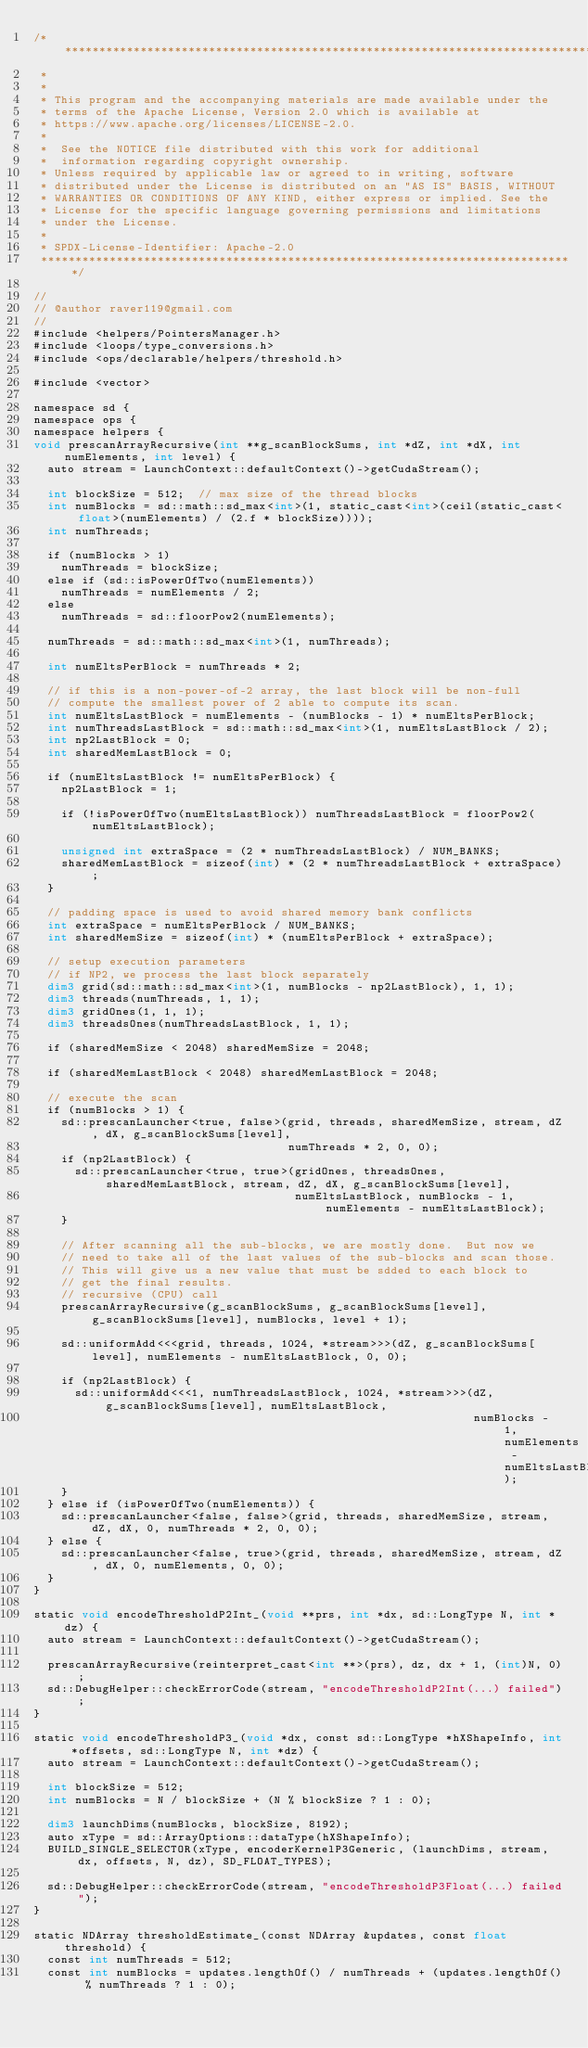<code> <loc_0><loc_0><loc_500><loc_500><_Cuda_>/* ******************************************************************************
 *
 *
 * This program and the accompanying materials are made available under the
 * terms of the Apache License, Version 2.0 which is available at
 * https://www.apache.org/licenses/LICENSE-2.0.
 *
 *  See the NOTICE file distributed with this work for additional
 *  information regarding copyright ownership.
 * Unless required by applicable law or agreed to in writing, software
 * distributed under the License is distributed on an "AS IS" BASIS, WITHOUT
 * WARRANTIES OR CONDITIONS OF ANY KIND, either express or implied. See the
 * License for the specific language governing permissions and limitations
 * under the License.
 *
 * SPDX-License-Identifier: Apache-2.0
 ******************************************************************************/

//
// @author raver119@gmail.com
//
#include <helpers/PointersManager.h>
#include <loops/type_conversions.h>
#include <ops/declarable/helpers/threshold.h>

#include <vector>

namespace sd {
namespace ops {
namespace helpers {
void prescanArrayRecursive(int **g_scanBlockSums, int *dZ, int *dX, int numElements, int level) {
  auto stream = LaunchContext::defaultContext()->getCudaStream();

  int blockSize = 512;  // max size of the thread blocks
  int numBlocks = sd::math::sd_max<int>(1, static_cast<int>(ceil(static_cast<float>(numElements) / (2.f * blockSize))));
  int numThreads;

  if (numBlocks > 1)
    numThreads = blockSize;
  else if (sd::isPowerOfTwo(numElements))
    numThreads = numElements / 2;
  else
    numThreads = sd::floorPow2(numElements);

  numThreads = sd::math::sd_max<int>(1, numThreads);

  int numEltsPerBlock = numThreads * 2;

  // if this is a non-power-of-2 array, the last block will be non-full
  // compute the smallest power of 2 able to compute its scan.
  int numEltsLastBlock = numElements - (numBlocks - 1) * numEltsPerBlock;
  int numThreadsLastBlock = sd::math::sd_max<int>(1, numEltsLastBlock / 2);
  int np2LastBlock = 0;
  int sharedMemLastBlock = 0;

  if (numEltsLastBlock != numEltsPerBlock) {
    np2LastBlock = 1;

    if (!isPowerOfTwo(numEltsLastBlock)) numThreadsLastBlock = floorPow2(numEltsLastBlock);

    unsigned int extraSpace = (2 * numThreadsLastBlock) / NUM_BANKS;
    sharedMemLastBlock = sizeof(int) * (2 * numThreadsLastBlock + extraSpace);
  }

  // padding space is used to avoid shared memory bank conflicts
  int extraSpace = numEltsPerBlock / NUM_BANKS;
  int sharedMemSize = sizeof(int) * (numEltsPerBlock + extraSpace);

  // setup execution parameters
  // if NP2, we process the last block separately
  dim3 grid(sd::math::sd_max<int>(1, numBlocks - np2LastBlock), 1, 1);
  dim3 threads(numThreads, 1, 1);
  dim3 gridOnes(1, 1, 1);
  dim3 threadsOnes(numThreadsLastBlock, 1, 1);

  if (sharedMemSize < 2048) sharedMemSize = 2048;

  if (sharedMemLastBlock < 2048) sharedMemLastBlock = 2048;

  // execute the scan
  if (numBlocks > 1) {
    sd::prescanLauncher<true, false>(grid, threads, sharedMemSize, stream, dZ, dX, g_scanBlockSums[level],
                                     numThreads * 2, 0, 0);
    if (np2LastBlock) {
      sd::prescanLauncher<true, true>(gridOnes, threadsOnes, sharedMemLastBlock, stream, dZ, dX, g_scanBlockSums[level],
                                      numEltsLastBlock, numBlocks - 1, numElements - numEltsLastBlock);
    }

    // After scanning all the sub-blocks, we are mostly done.  But now we
    // need to take all of the last values of the sub-blocks and scan those.
    // This will give us a new value that must be sdded to each block to
    // get the final results.
    // recursive (CPU) call
    prescanArrayRecursive(g_scanBlockSums, g_scanBlockSums[level], g_scanBlockSums[level], numBlocks, level + 1);

    sd::uniformAdd<<<grid, threads, 1024, *stream>>>(dZ, g_scanBlockSums[level], numElements - numEltsLastBlock, 0, 0);

    if (np2LastBlock) {
      sd::uniformAdd<<<1, numThreadsLastBlock, 1024, *stream>>>(dZ, g_scanBlockSums[level], numEltsLastBlock,
                                                                numBlocks - 1, numElements - numEltsLastBlock);
    }
  } else if (isPowerOfTwo(numElements)) {
    sd::prescanLauncher<false, false>(grid, threads, sharedMemSize, stream, dZ, dX, 0, numThreads * 2, 0, 0);
  } else {
    sd::prescanLauncher<false, true>(grid, threads, sharedMemSize, stream, dZ, dX, 0, numElements, 0, 0);
  }
}

static void encodeThresholdP2Int_(void **prs, int *dx, sd::LongType N, int *dz) {
  auto stream = LaunchContext::defaultContext()->getCudaStream();

  prescanArrayRecursive(reinterpret_cast<int **>(prs), dz, dx + 1, (int)N, 0);
  sd::DebugHelper::checkErrorCode(stream, "encodeThresholdP2Int(...) failed");
}

static void encodeThresholdP3_(void *dx, const sd::LongType *hXShapeInfo, int *offsets, sd::LongType N, int *dz) {
  auto stream = LaunchContext::defaultContext()->getCudaStream();

  int blockSize = 512;
  int numBlocks = N / blockSize + (N % blockSize ? 1 : 0);

  dim3 launchDims(numBlocks, blockSize, 8192);
  auto xType = sd::ArrayOptions::dataType(hXShapeInfo);
  BUILD_SINGLE_SELECTOR(xType, encoderKernelP3Generic, (launchDims, stream, dx, offsets, N, dz), SD_FLOAT_TYPES);

  sd::DebugHelper::checkErrorCode(stream, "encodeThresholdP3Float(...) failed");
}

static NDArray thresholdEstimate_(const NDArray &updates, const float threshold) {
  const int numThreads = 512;
  const int numBlocks = updates.lengthOf() / numThreads + (updates.lengthOf() % numThreads ? 1 : 0);
</code> 